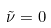<formula> <loc_0><loc_0><loc_500><loc_500>\tilde { \nu } = 0</formula> 